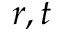<formula> <loc_0><loc_0><loc_500><loc_500>r , t</formula> 